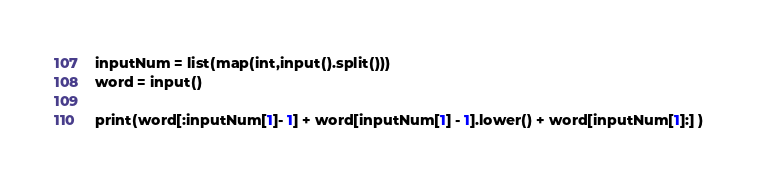Convert code to text. <code><loc_0><loc_0><loc_500><loc_500><_Python_>inputNum = list(map(int,input().split()))
word = input()

print(word[:inputNum[1]- 1] + word[inputNum[1] - 1].lower() + word[inputNum[1]:] )</code> 